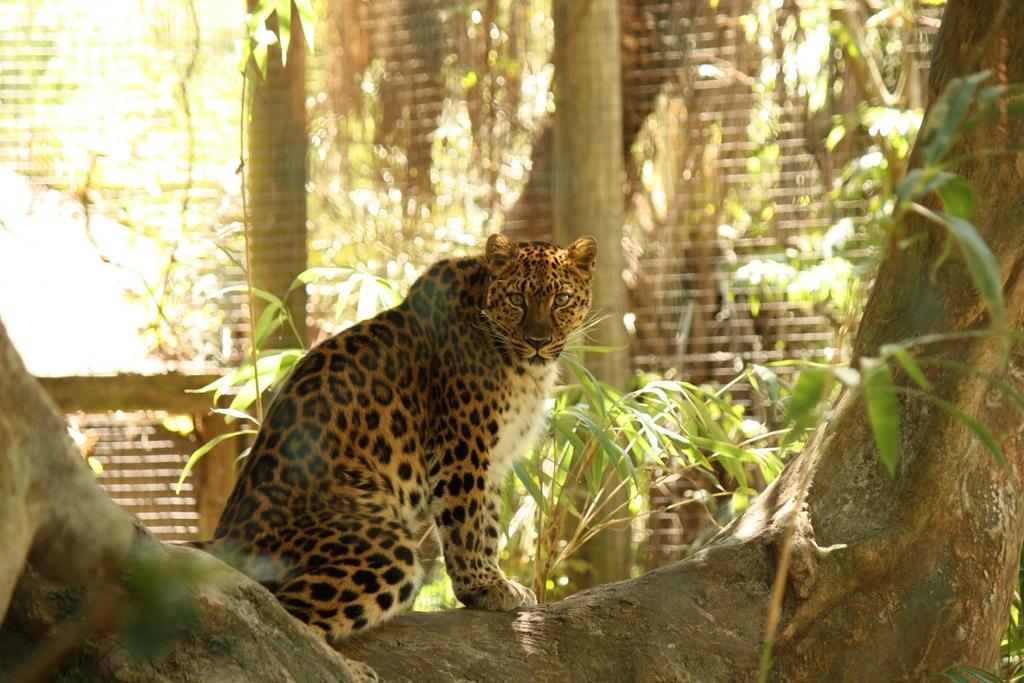What animal is in the center of the image? There is a cheetah in the center of the image. What can be seen in the background of the image? There is a net and greenery in the background of the image. What type of crack is visible on the floor in the image? There is no floor present in the image, as it features a cheetah in the center and a net and greenery in the background. 